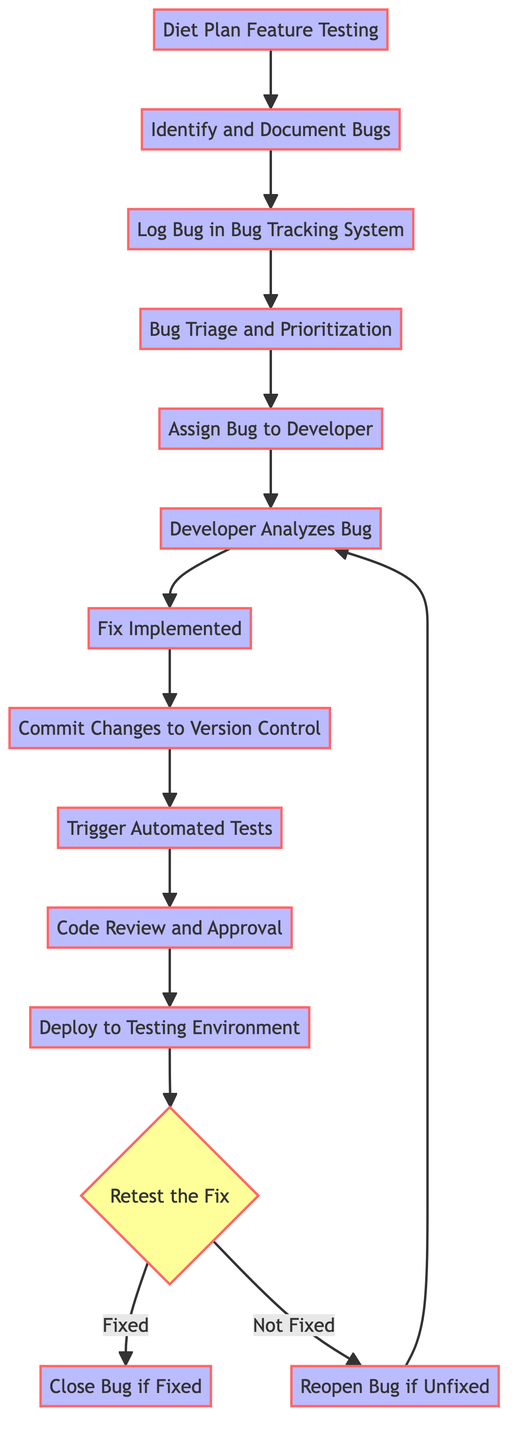What is the first step in the bug reporting process? The first step is "Diet Plan Feature Testing", which initiates the bug reporting process.
Answer: Diet Plan Feature Testing How many nodes are present in the diagram? The diagram contains a total of 14 nodes, each representing a step in the bug reporting and resolution process.
Answer: 14 What node comes directly after "Log Bug in Bug Tracking System"? The node that comes directly after "Log Bug in Bug Tracking System" is "Bug Triage and Prioritization", following the directed edge from the logging step.
Answer: Bug Triage and Prioritization What are the two outcomes after "Retest the Fix"? The two outcomes after "Retest the Fix" are "Close Bug if Fixed" and "Reopen Bug if Unfixed", indicating the result of the testing phase.
Answer: Close Bug if Fixed, Reopen Bug if Unfixed How many edges are there in total? The diagram has a total of 13 edges, which represent the connections between the various nodes in the bug reporting process.
Answer: 13 Which node follows "Developer Analyzes Bug"? Following "Developer Analyzes Bug", the next node is "Fix Implemented", representing the stage where the developer applies the necessary fixes.
Answer: Fix Implemented What is the relationship between "Close Bug if Fixed" and "Retest the Fix"? "Close Bug if Fixed" is a terminal state that depends on the outcome of "Retest the Fix"; if the fix is satisfactory, the bug is closed.
Answer: dependent What step follows "Trigger Automated Tests"? The step that follows "Trigger Automated Tests" is "Code Review and Approval", indicating the process of reviewing the new code changes for quality assurance.
Answer: Code Review and Approval If a bug is reopened, which node does it lead to? If a bug is reopened, it leads back to "Developer Analyzes Bug" where it will be analyzed again for further action.
Answer: Developer Analyzes Bug 